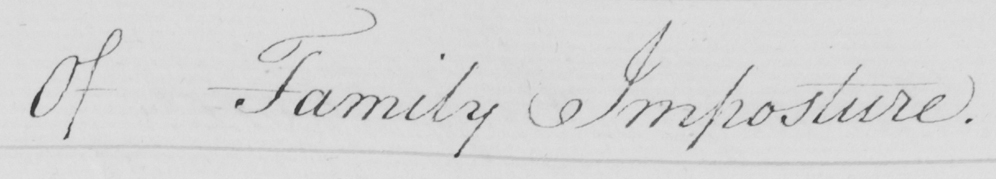Please transcribe the handwritten text in this image. Of Family Imposture . 